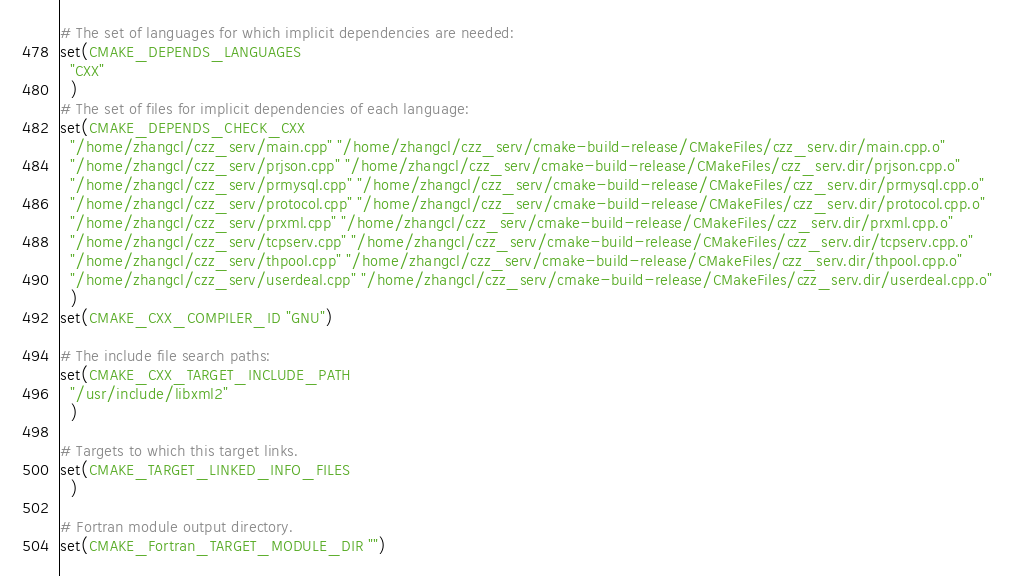Convert code to text. <code><loc_0><loc_0><loc_500><loc_500><_CMake_># The set of languages for which implicit dependencies are needed:
set(CMAKE_DEPENDS_LANGUAGES
  "CXX"
  )
# The set of files for implicit dependencies of each language:
set(CMAKE_DEPENDS_CHECK_CXX
  "/home/zhangcl/czz_serv/main.cpp" "/home/zhangcl/czz_serv/cmake-build-release/CMakeFiles/czz_serv.dir/main.cpp.o"
  "/home/zhangcl/czz_serv/prjson.cpp" "/home/zhangcl/czz_serv/cmake-build-release/CMakeFiles/czz_serv.dir/prjson.cpp.o"
  "/home/zhangcl/czz_serv/prmysql.cpp" "/home/zhangcl/czz_serv/cmake-build-release/CMakeFiles/czz_serv.dir/prmysql.cpp.o"
  "/home/zhangcl/czz_serv/protocol.cpp" "/home/zhangcl/czz_serv/cmake-build-release/CMakeFiles/czz_serv.dir/protocol.cpp.o"
  "/home/zhangcl/czz_serv/prxml.cpp" "/home/zhangcl/czz_serv/cmake-build-release/CMakeFiles/czz_serv.dir/prxml.cpp.o"
  "/home/zhangcl/czz_serv/tcpserv.cpp" "/home/zhangcl/czz_serv/cmake-build-release/CMakeFiles/czz_serv.dir/tcpserv.cpp.o"
  "/home/zhangcl/czz_serv/thpool.cpp" "/home/zhangcl/czz_serv/cmake-build-release/CMakeFiles/czz_serv.dir/thpool.cpp.o"
  "/home/zhangcl/czz_serv/userdeal.cpp" "/home/zhangcl/czz_serv/cmake-build-release/CMakeFiles/czz_serv.dir/userdeal.cpp.o"
  )
set(CMAKE_CXX_COMPILER_ID "GNU")

# The include file search paths:
set(CMAKE_CXX_TARGET_INCLUDE_PATH
  "/usr/include/libxml2"
  )

# Targets to which this target links.
set(CMAKE_TARGET_LINKED_INFO_FILES
  )

# Fortran module output directory.
set(CMAKE_Fortran_TARGET_MODULE_DIR "")
</code> 